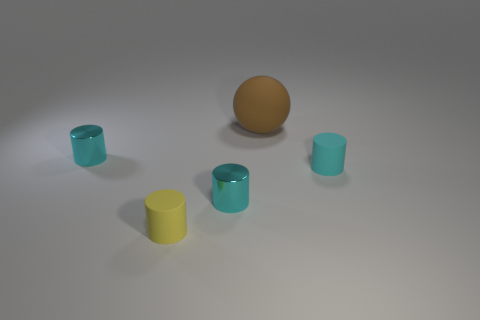How many cyan cylinders must be subtracted to get 1 cyan cylinders? 2 Subtract all yellow cylinders. How many cylinders are left? 3 Add 5 rubber blocks. How many objects exist? 10 Subtract all cyan blocks. How many cyan cylinders are left? 3 Subtract all yellow cylinders. How many cylinders are left? 3 Subtract 2 cylinders. How many cylinders are left? 2 Subtract all spheres. How many objects are left? 4 Subtract 0 gray cubes. How many objects are left? 5 Subtract all green balls. Subtract all brown cubes. How many balls are left? 1 Subtract all yellow things. Subtract all large balls. How many objects are left? 3 